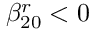<formula> <loc_0><loc_0><loc_500><loc_500>\beta _ { 2 0 } ^ { r } < 0</formula> 